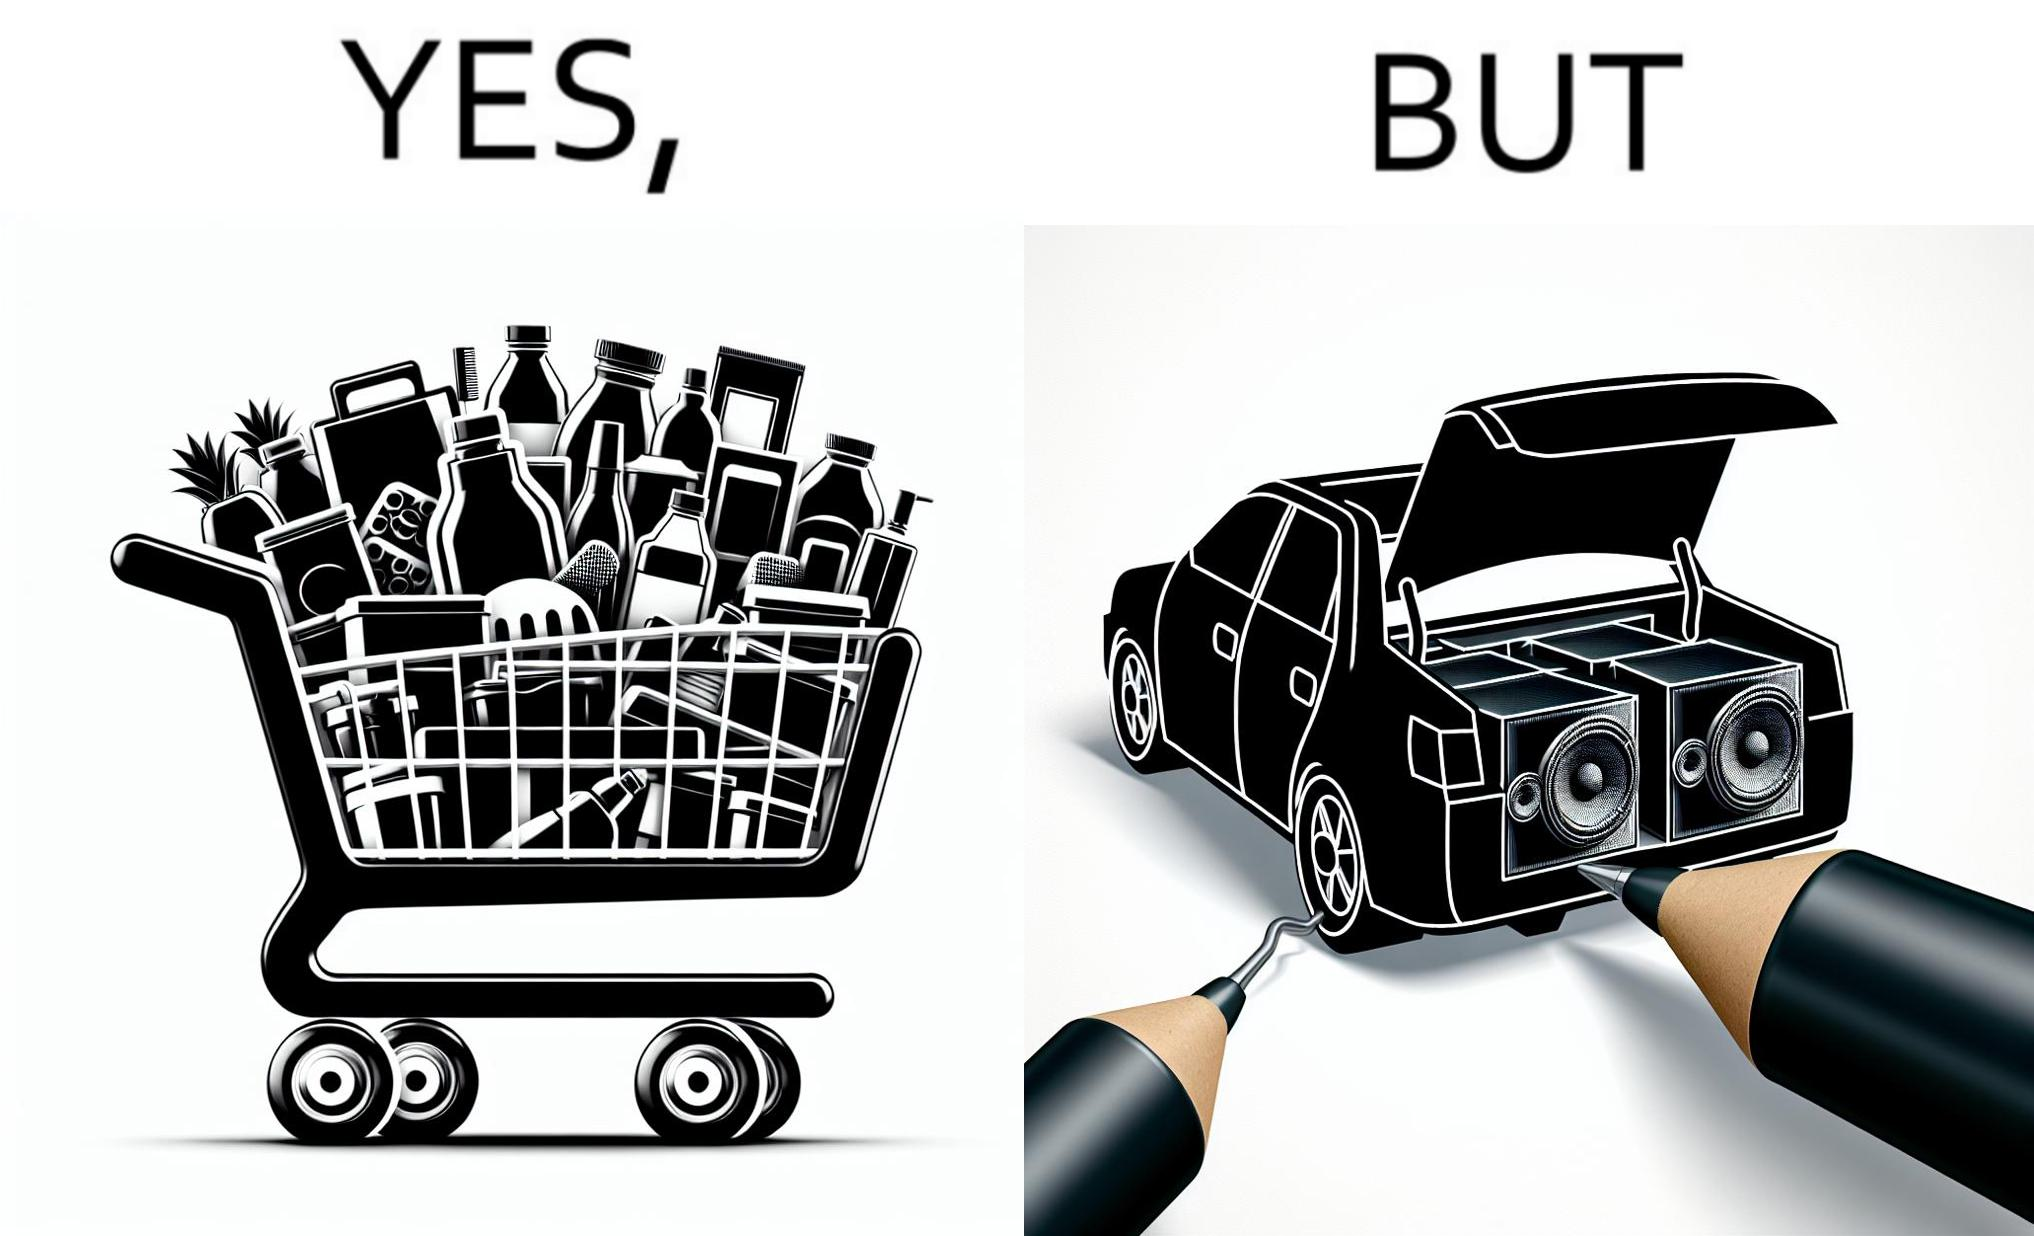Provide a description of this image. The image is ironic, because a car trunk was earlier designed to keep some extra luggage or things but people nowadays get speakers installed in the trunk which in turn reduces the space in the trunk and making it difficult for people to store the extra luggage in the trunk 